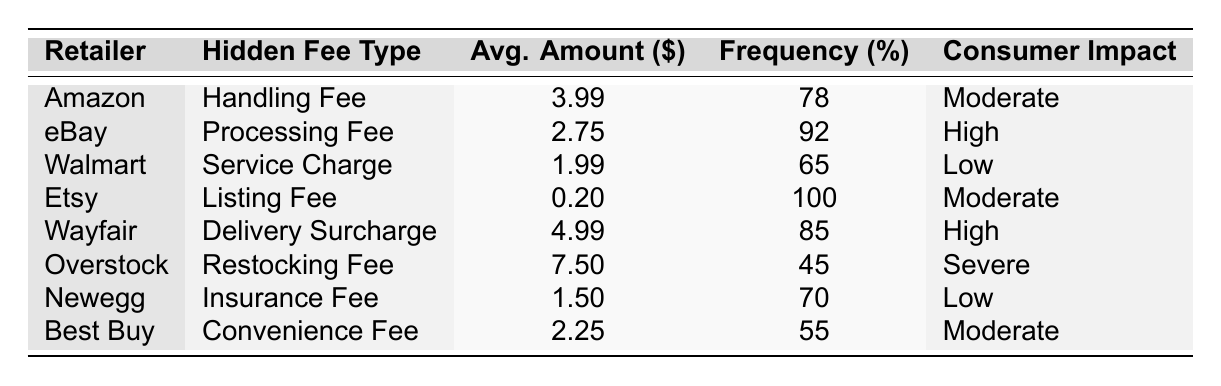What is the average hidden fee amount for retailers? To find the average hidden fee amount, we need to sum all average amounts and divide by the number of retailers. The sums are (3.99 + 2.75 + 1.99 + 0.20 + 4.99 + 7.50 + 1.50 + 2.25) = 24.17. There are 8 retailers, so the average is 24.17 / 8 = 3.02.
Answer: 3.02 Which retailer has the highest hidden fee? By checking the 'Average Amount' column, we see that Overstock has the highest fee of 7.50.
Answer: Overstock What percentage of retailers charge a processing fee? To determine this, we can count the instances of the 'Processing Fee' and relate it to the total number of retailers. Only eBay has a processing fee, so the calculation is (1/8) * 100 = 12.5%.
Answer: 12.5% Is the average handling fee higher than the average delivery surcharge? The average handling fee is 3.99 and the delivery surcharge is 4.99. Since 3.99 is less than 4.99, we confirm that the handling fee is not higher.
Answer: No How many retailers charge a high consumer impact? We can count the instances where consumer impact is labeled as 'High'. eBay and Wayfair both have this designation, which makes a total of 2 retailers.
Answer: 2 What is the difference in average amounts between the highest and lowest fees? The highest fee is 7.50 (Overstock) and the lowest is 0.20 (Etsy). The difference is 7.50 - 0.20 = 7.30.
Answer: 7.30 Which retailer has a service charge and what is the average amount for it? Checking the 'Hidden Fee Type' column reveals that Walmart has the service charge. The average amount is 1.99.
Answer: Walmart, 1.99 What unique types of hidden fees are listed in the table? By examining the 'Hidden Fee Type' column, we extract the unique fee types: Handling Fee, Processing Fee, Service Charge, Listing Fee, Delivery Surcharge, Restocking Fee, Insurance Fee, and Convenience Fee, making a total of 8 unique types.
Answer: 8 